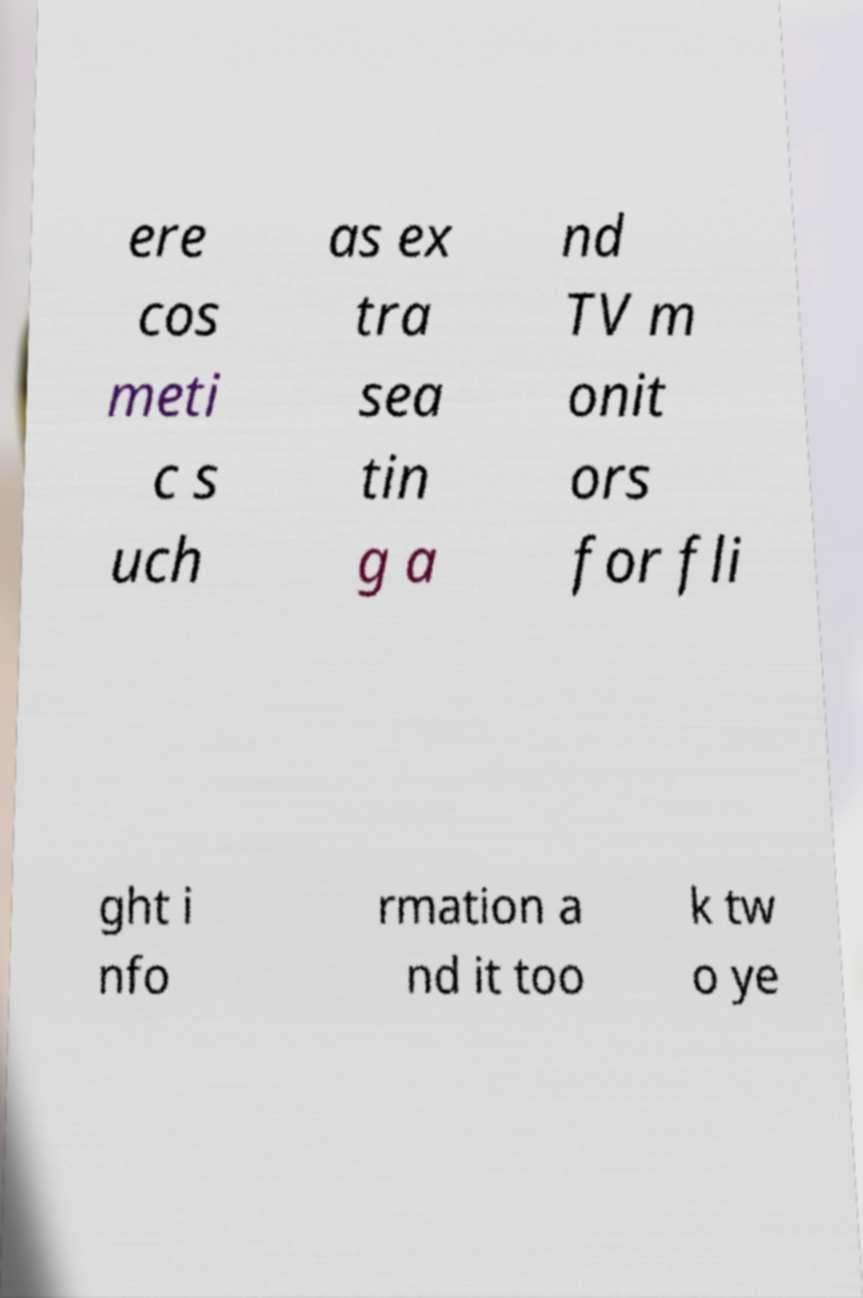There's text embedded in this image that I need extracted. Can you transcribe it verbatim? ere cos meti c s uch as ex tra sea tin g a nd TV m onit ors for fli ght i nfo rmation a nd it too k tw o ye 